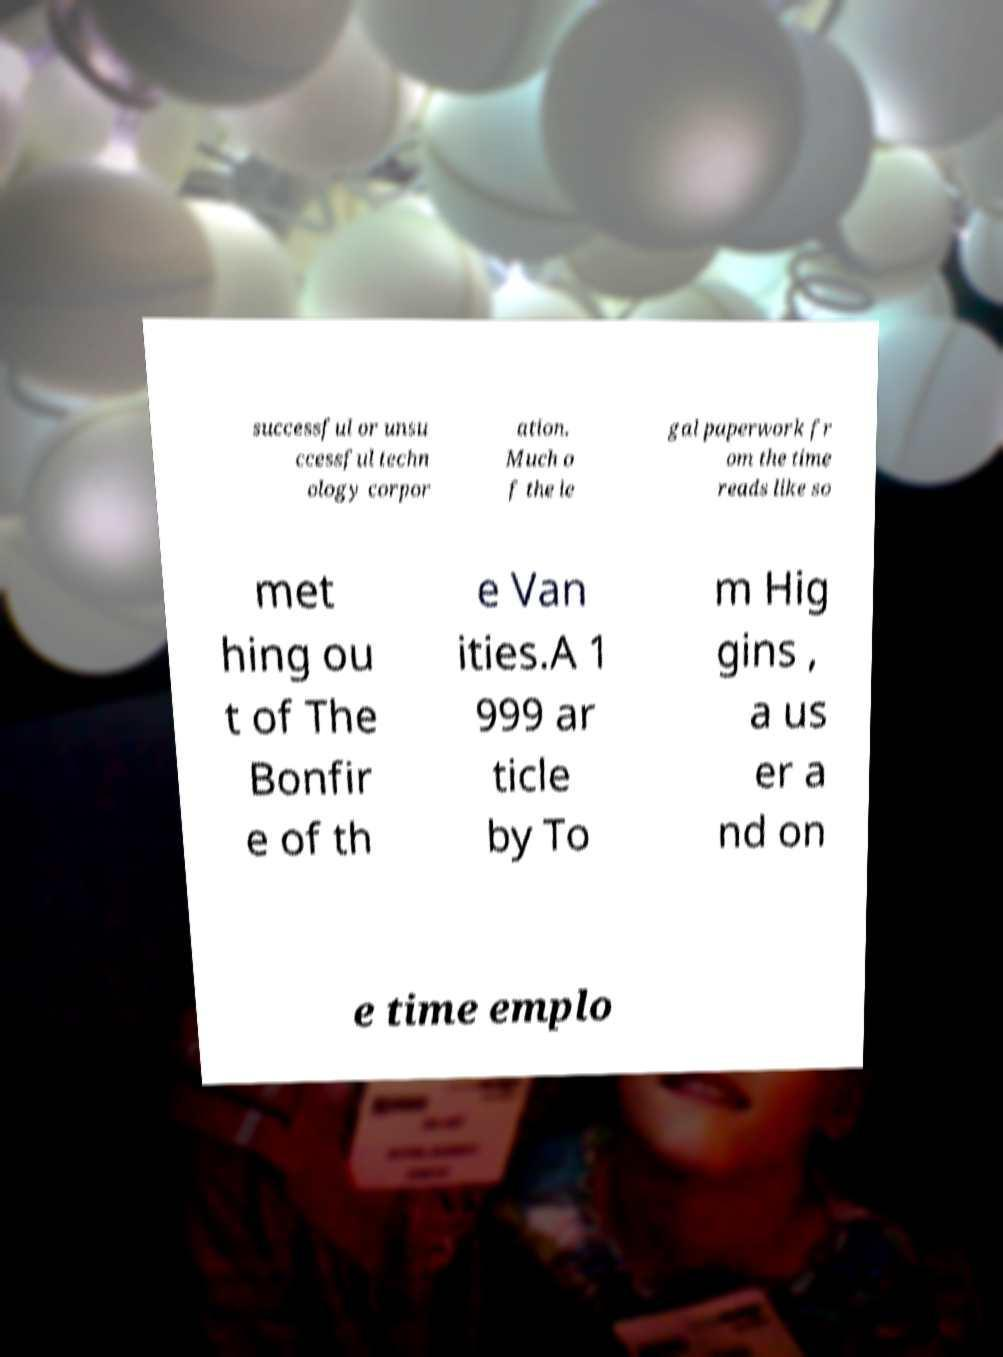What messages or text are displayed in this image? I need them in a readable, typed format. successful or unsu ccessful techn ology corpor ation. Much o f the le gal paperwork fr om the time reads like so met hing ou t of The Bonfir e of th e Van ities.A 1 999 ar ticle by To m Hig gins , a us er a nd on e time emplo 